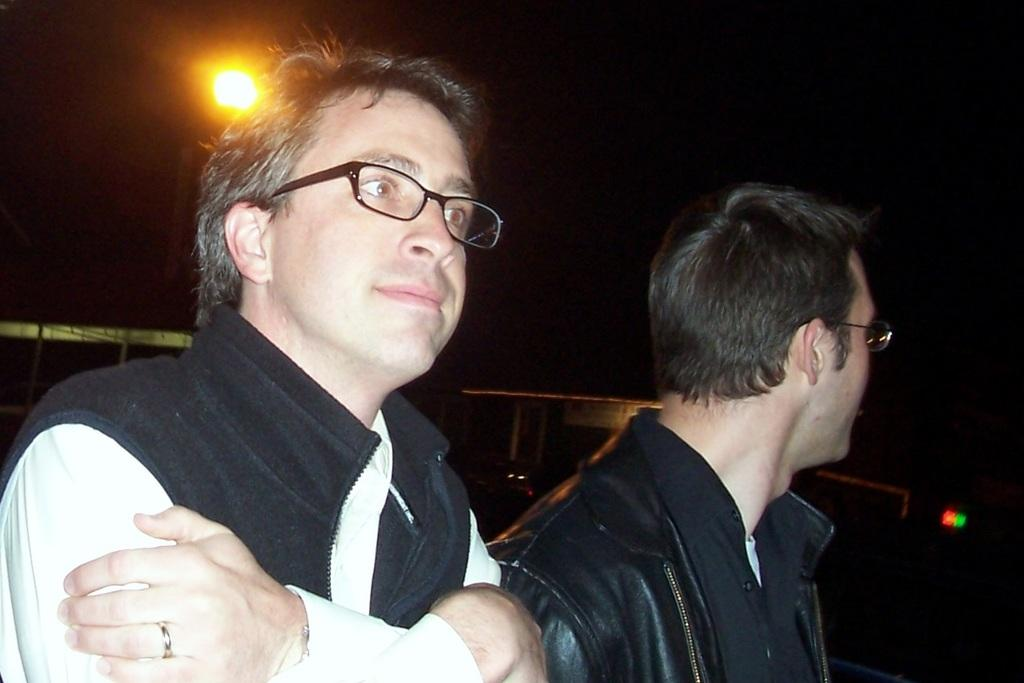How many people are in the foreground of the image? There are two people in the foreground of the image. What are the people wearing in the image? The people are wearing spectacles in the image. What can be seen in the background of the image? Sky, a light pole, and vehicles can be seen in the background of the image. What grade of wood is used for the shelf in the image? There is no shelf present in the image, so it is not possible to determine the grade of wood used. 